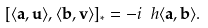Convert formula to latex. <formula><loc_0><loc_0><loc_500><loc_500>[ \langle { \mathbf a } , { \mathbf u } \rangle , \langle { \mathbf b } , { \mathbf v } \rangle ] _ { * } = - i \ h \langle { \mathbf a } , { \mathbf b } \rangle .</formula> 